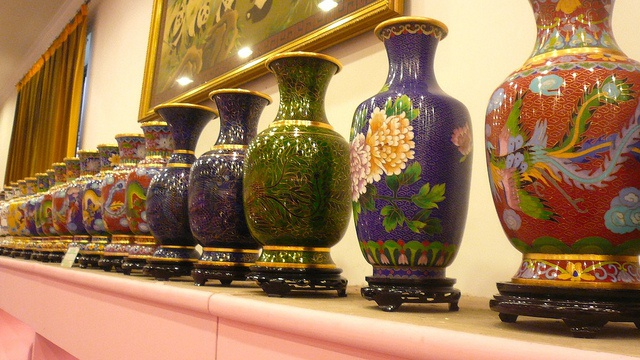Describe the objects in this image and their specific colors. I can see vase in gray, maroon, brown, and black tones, vase in gray, black, olive, and purple tones, vase in gray, black, olive, and maroon tones, vase in gray, black, and maroon tones, and vase in gray, black, and maroon tones in this image. 